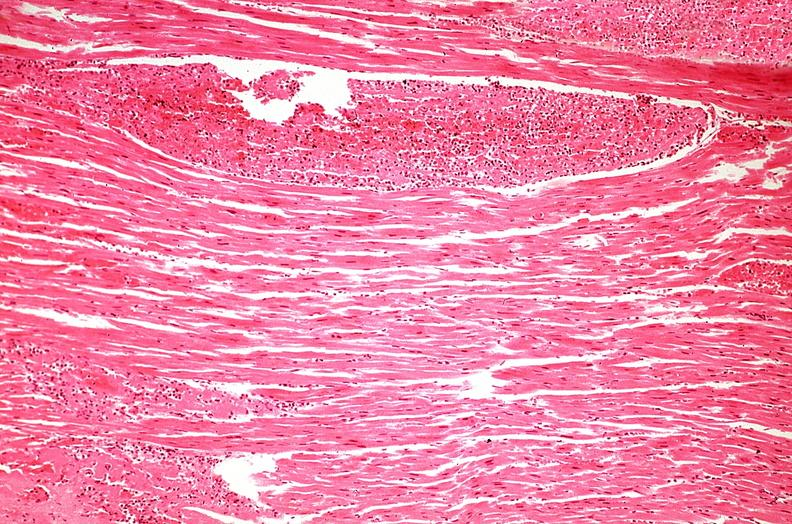does this image show heart, myocardial infarction, wavey fiber change, necrtosis, hemorrhage, and dissection?
Answer the question using a single word or phrase. Yes 